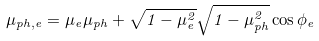<formula> <loc_0><loc_0><loc_500><loc_500>\mu _ { p h , e } = \mu _ { e } \mu _ { p h } + \sqrt { 1 - \mu _ { e } ^ { 2 } } \sqrt { 1 - \mu _ { p h } ^ { 2 } } \cos \phi _ { e }</formula> 